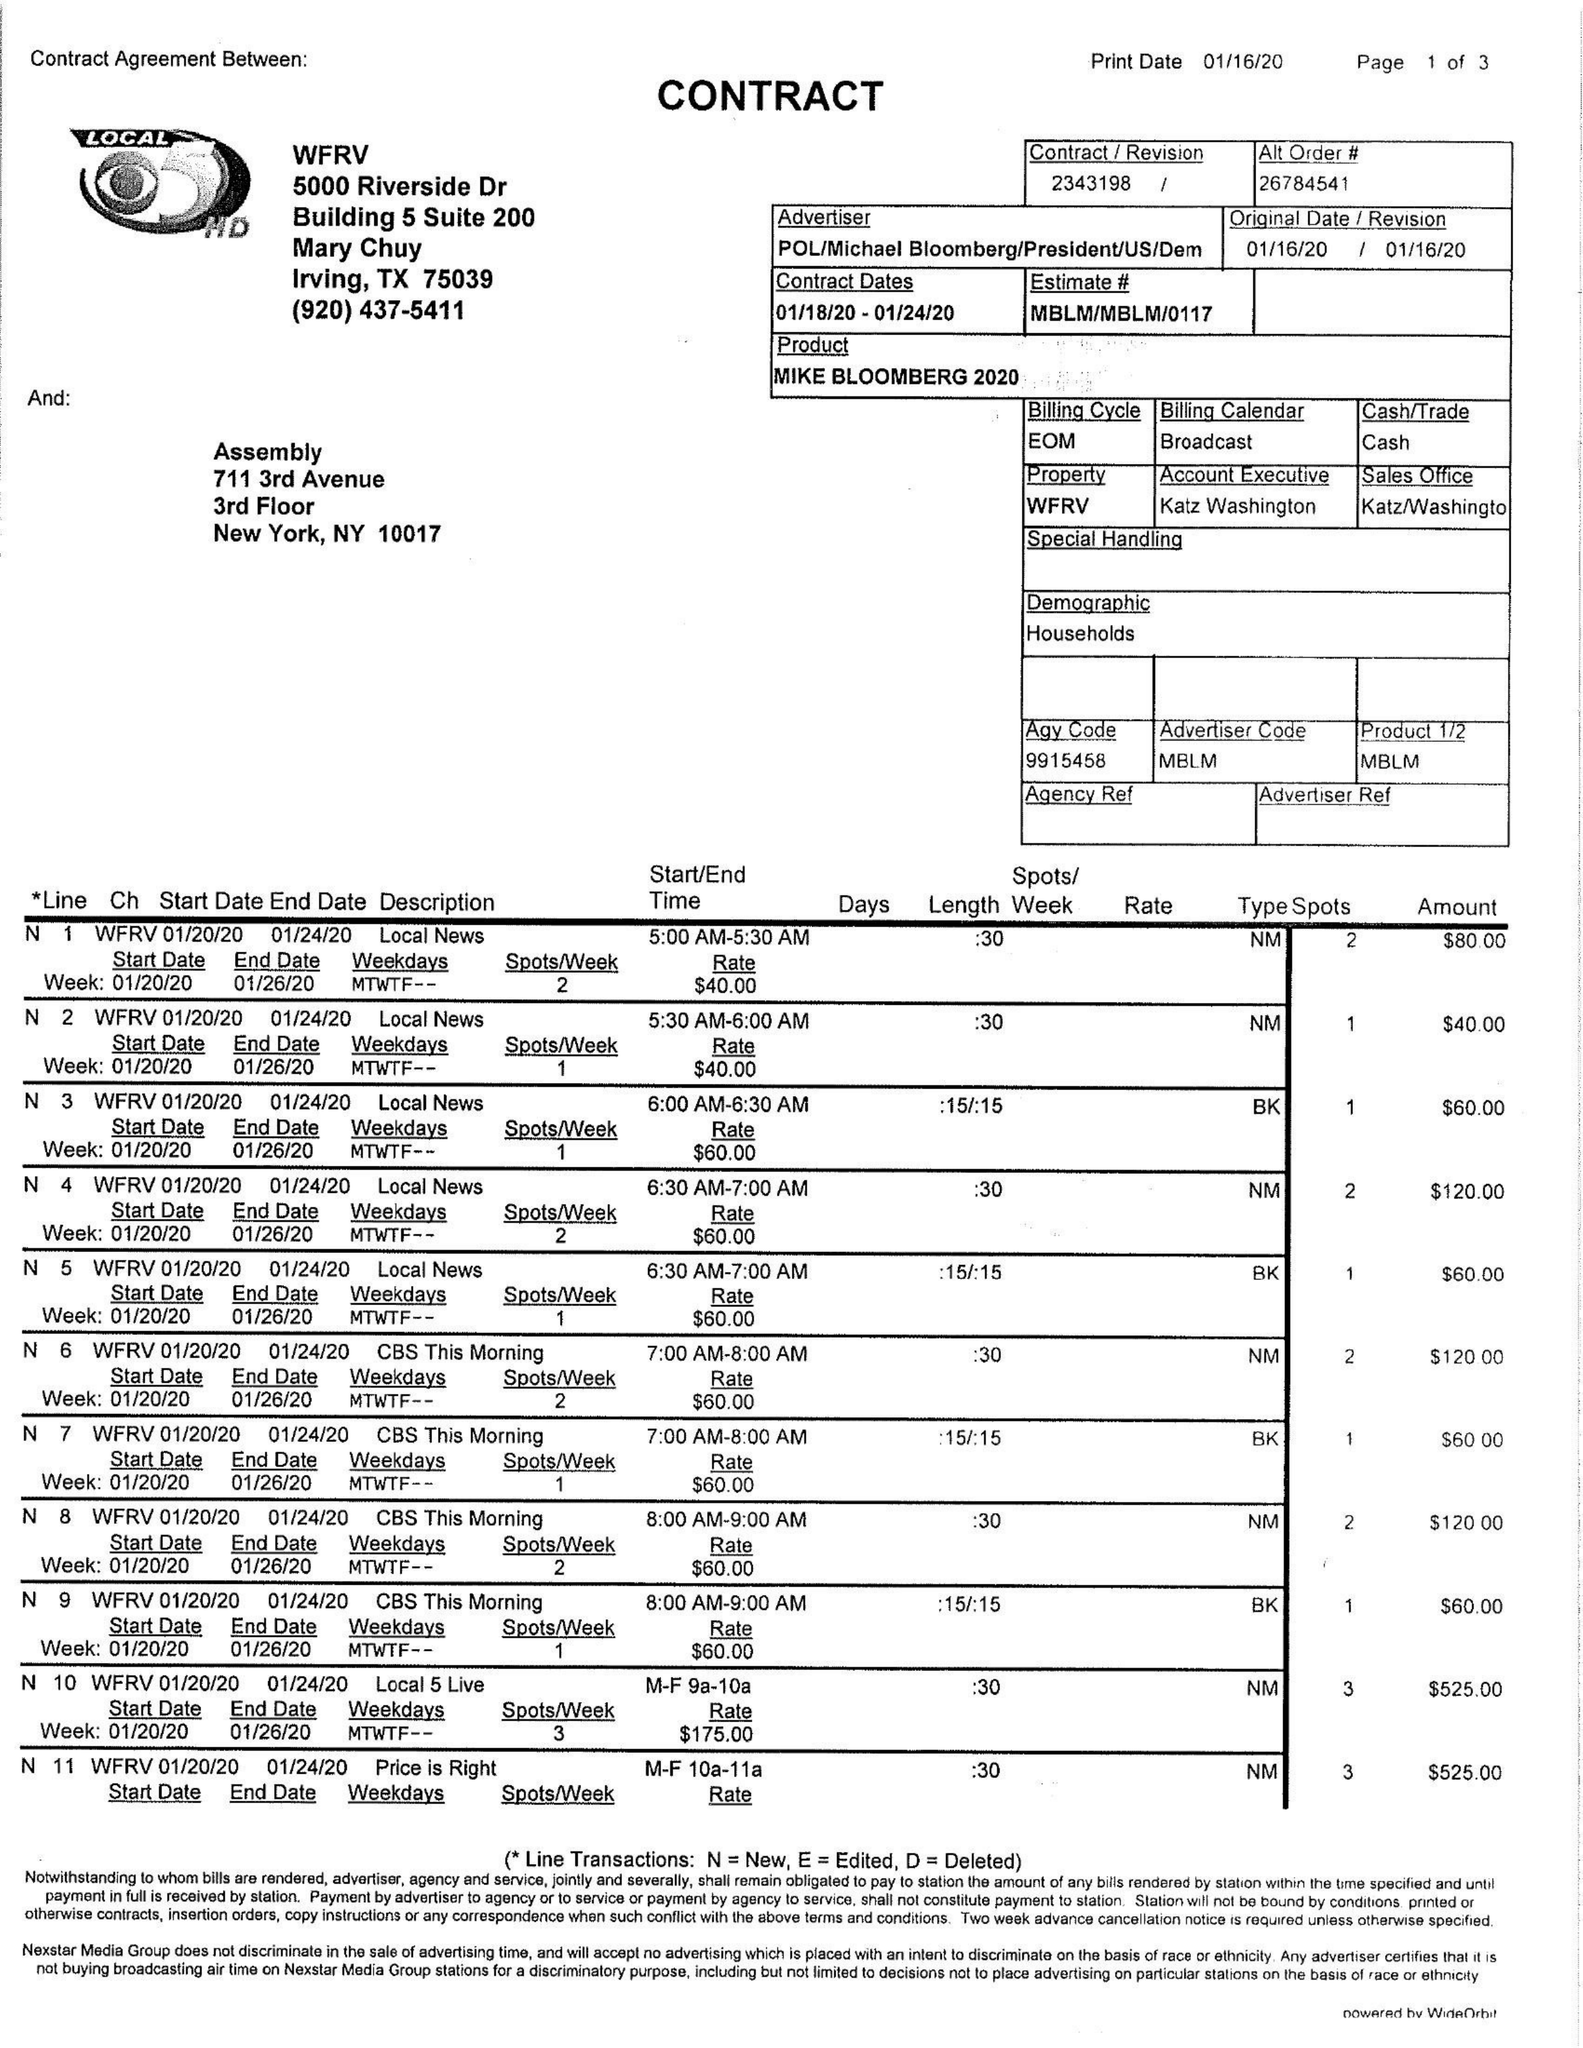What is the value for the advertiser?
Answer the question using a single word or phrase. POL/MICHAELBLOOMBERG/PRESIDENT/US/DEM 